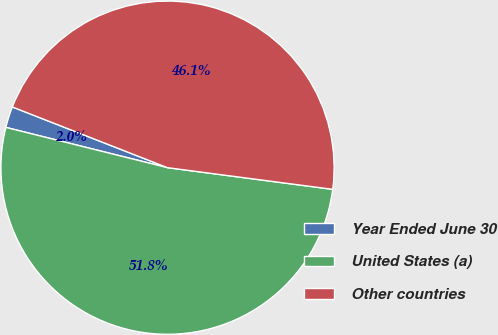<chart> <loc_0><loc_0><loc_500><loc_500><pie_chart><fcel>Year Ended June 30<fcel>United States (a)<fcel>Other countries<nl><fcel>2.05%<fcel>51.81%<fcel>46.14%<nl></chart> 